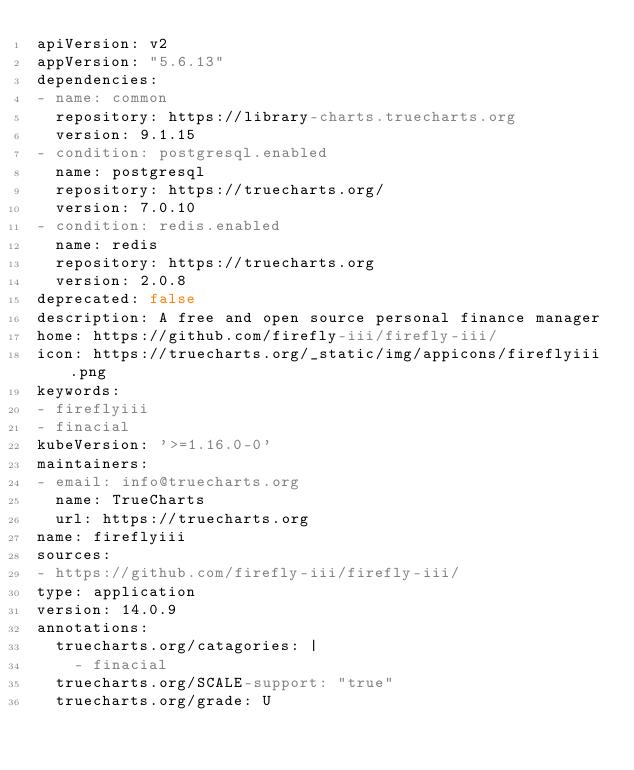<code> <loc_0><loc_0><loc_500><loc_500><_YAML_>apiVersion: v2
appVersion: "5.6.13"
dependencies:
- name: common
  repository: https://library-charts.truecharts.org
  version: 9.1.15
- condition: postgresql.enabled
  name: postgresql
  repository: https://truecharts.org/
  version: 7.0.10
- condition: redis.enabled
  name: redis
  repository: https://truecharts.org
  version: 2.0.8
deprecated: false
description: A free and open source personal finance manager
home: https://github.com/firefly-iii/firefly-iii/
icon: https://truecharts.org/_static/img/appicons/fireflyiii.png
keywords:
- fireflyiii
- finacial
kubeVersion: '>=1.16.0-0'
maintainers:
- email: info@truecharts.org
  name: TrueCharts
  url: https://truecharts.org
name: fireflyiii
sources:
- https://github.com/firefly-iii/firefly-iii/
type: application
version: 14.0.9
annotations:
  truecharts.org/catagories: |
    - finacial
  truecharts.org/SCALE-support: "true"
  truecharts.org/grade: U
</code> 